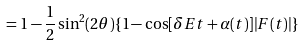Convert formula to latex. <formula><loc_0><loc_0><loc_500><loc_500>= 1 - \frac { 1 } { 2 } \sin ^ { 2 } ( 2 \theta ) \{ 1 - \cos [ \delta E t + \alpha ( t ) ] | F ( t ) | \}</formula> 